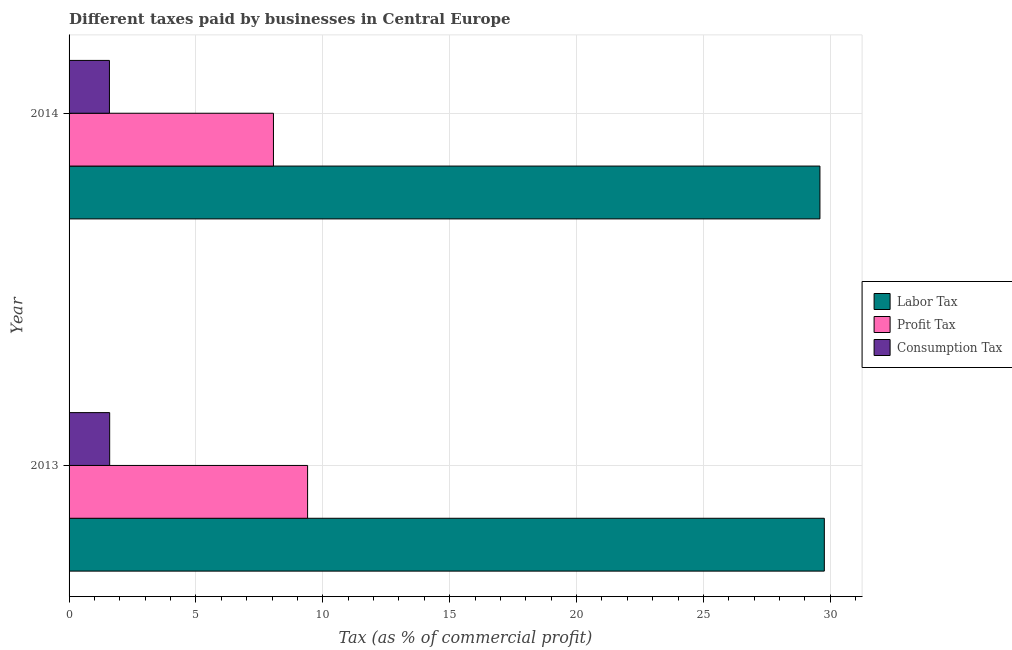How many different coloured bars are there?
Give a very brief answer. 3. How many groups of bars are there?
Offer a terse response. 2. Are the number of bars per tick equal to the number of legend labels?
Keep it short and to the point. Yes. Are the number of bars on each tick of the Y-axis equal?
Ensure brevity in your answer.  Yes. How many bars are there on the 2nd tick from the top?
Make the answer very short. 3. In how many cases, is the number of bars for a given year not equal to the number of legend labels?
Offer a very short reply. 0. What is the percentage of consumption tax in 2014?
Provide a short and direct response. 1.59. Across all years, what is the minimum percentage of profit tax?
Offer a very short reply. 8.05. What is the total percentage of labor tax in the graph?
Give a very brief answer. 59.35. What is the difference between the percentage of labor tax in 2013 and that in 2014?
Give a very brief answer. 0.17. What is the difference between the percentage of consumption tax in 2013 and the percentage of labor tax in 2014?
Keep it short and to the point. -27.99. What is the average percentage of consumption tax per year?
Give a very brief answer. 1.59. In the year 2014, what is the difference between the percentage of profit tax and percentage of consumption tax?
Provide a succinct answer. 6.46. In how many years, is the percentage of profit tax greater than 30 %?
Give a very brief answer. 0. What is the ratio of the percentage of labor tax in 2013 to that in 2014?
Provide a succinct answer. 1.01. Is the percentage of labor tax in 2013 less than that in 2014?
Give a very brief answer. No. In how many years, is the percentage of labor tax greater than the average percentage of labor tax taken over all years?
Keep it short and to the point. 1. What does the 2nd bar from the top in 2013 represents?
Offer a terse response. Profit Tax. What does the 3rd bar from the bottom in 2013 represents?
Ensure brevity in your answer.  Consumption Tax. Are the values on the major ticks of X-axis written in scientific E-notation?
Keep it short and to the point. No. Does the graph contain any zero values?
Provide a succinct answer. No. Does the graph contain grids?
Provide a succinct answer. Yes. Where does the legend appear in the graph?
Keep it short and to the point. Center right. How many legend labels are there?
Offer a very short reply. 3. How are the legend labels stacked?
Provide a succinct answer. Vertical. What is the title of the graph?
Keep it short and to the point. Different taxes paid by businesses in Central Europe. What is the label or title of the X-axis?
Keep it short and to the point. Tax (as % of commercial profit). What is the Tax (as % of commercial profit) of Labor Tax in 2013?
Your response must be concise. 29.76. What is the Tax (as % of commercial profit) of Consumption Tax in 2013?
Provide a succinct answer. 1.6. What is the Tax (as % of commercial profit) in Labor Tax in 2014?
Your answer should be very brief. 29.59. What is the Tax (as % of commercial profit) of Profit Tax in 2014?
Ensure brevity in your answer.  8.05. What is the Tax (as % of commercial profit) in Consumption Tax in 2014?
Your answer should be very brief. 1.59. Across all years, what is the maximum Tax (as % of commercial profit) in Labor Tax?
Make the answer very short. 29.76. Across all years, what is the maximum Tax (as % of commercial profit) of Consumption Tax?
Your response must be concise. 1.6. Across all years, what is the minimum Tax (as % of commercial profit) in Labor Tax?
Offer a terse response. 29.59. Across all years, what is the minimum Tax (as % of commercial profit) in Profit Tax?
Make the answer very short. 8.05. Across all years, what is the minimum Tax (as % of commercial profit) of Consumption Tax?
Ensure brevity in your answer.  1.59. What is the total Tax (as % of commercial profit) of Labor Tax in the graph?
Give a very brief answer. 59.35. What is the total Tax (as % of commercial profit) in Profit Tax in the graph?
Your response must be concise. 17.45. What is the total Tax (as % of commercial profit) in Consumption Tax in the graph?
Your answer should be very brief. 3.19. What is the difference between the Tax (as % of commercial profit) of Labor Tax in 2013 and that in 2014?
Your answer should be very brief. 0.17. What is the difference between the Tax (as % of commercial profit) in Profit Tax in 2013 and that in 2014?
Offer a very short reply. 1.35. What is the difference between the Tax (as % of commercial profit) of Consumption Tax in 2013 and that in 2014?
Your response must be concise. 0.01. What is the difference between the Tax (as % of commercial profit) in Labor Tax in 2013 and the Tax (as % of commercial profit) in Profit Tax in 2014?
Offer a terse response. 21.71. What is the difference between the Tax (as % of commercial profit) in Labor Tax in 2013 and the Tax (as % of commercial profit) in Consumption Tax in 2014?
Offer a terse response. 28.17. What is the difference between the Tax (as % of commercial profit) in Profit Tax in 2013 and the Tax (as % of commercial profit) in Consumption Tax in 2014?
Ensure brevity in your answer.  7.81. What is the average Tax (as % of commercial profit) in Labor Tax per year?
Your answer should be very brief. 29.68. What is the average Tax (as % of commercial profit) of Profit Tax per year?
Offer a terse response. 8.73. What is the average Tax (as % of commercial profit) of Consumption Tax per year?
Your response must be concise. 1.6. In the year 2013, what is the difference between the Tax (as % of commercial profit) in Labor Tax and Tax (as % of commercial profit) in Profit Tax?
Provide a short and direct response. 20.36. In the year 2013, what is the difference between the Tax (as % of commercial profit) of Labor Tax and Tax (as % of commercial profit) of Consumption Tax?
Keep it short and to the point. 28.16. In the year 2014, what is the difference between the Tax (as % of commercial profit) of Labor Tax and Tax (as % of commercial profit) of Profit Tax?
Provide a short and direct response. 21.54. In the year 2014, what is the difference between the Tax (as % of commercial profit) in Profit Tax and Tax (as % of commercial profit) in Consumption Tax?
Your answer should be very brief. 6.46. What is the ratio of the Tax (as % of commercial profit) of Labor Tax in 2013 to that in 2014?
Your answer should be very brief. 1.01. What is the ratio of the Tax (as % of commercial profit) of Profit Tax in 2013 to that in 2014?
Provide a succinct answer. 1.17. What is the difference between the highest and the second highest Tax (as % of commercial profit) of Labor Tax?
Provide a succinct answer. 0.17. What is the difference between the highest and the second highest Tax (as % of commercial profit) in Profit Tax?
Provide a succinct answer. 1.35. What is the difference between the highest and the second highest Tax (as % of commercial profit) in Consumption Tax?
Your answer should be very brief. 0.01. What is the difference between the highest and the lowest Tax (as % of commercial profit) of Labor Tax?
Make the answer very short. 0.17. What is the difference between the highest and the lowest Tax (as % of commercial profit) of Profit Tax?
Offer a terse response. 1.35. What is the difference between the highest and the lowest Tax (as % of commercial profit) in Consumption Tax?
Ensure brevity in your answer.  0.01. 